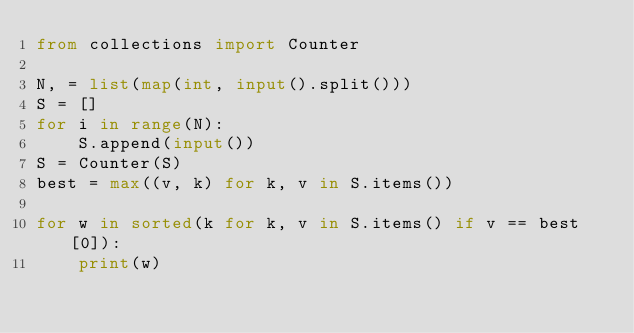Convert code to text. <code><loc_0><loc_0><loc_500><loc_500><_Python_>from collections import Counter

N, = list(map(int, input().split()))
S = []
for i in range(N):
    S.append(input())
S = Counter(S)
best = max((v, k) for k, v in S.items())

for w in sorted(k for k, v in S.items() if v == best[0]):
    print(w)
</code> 